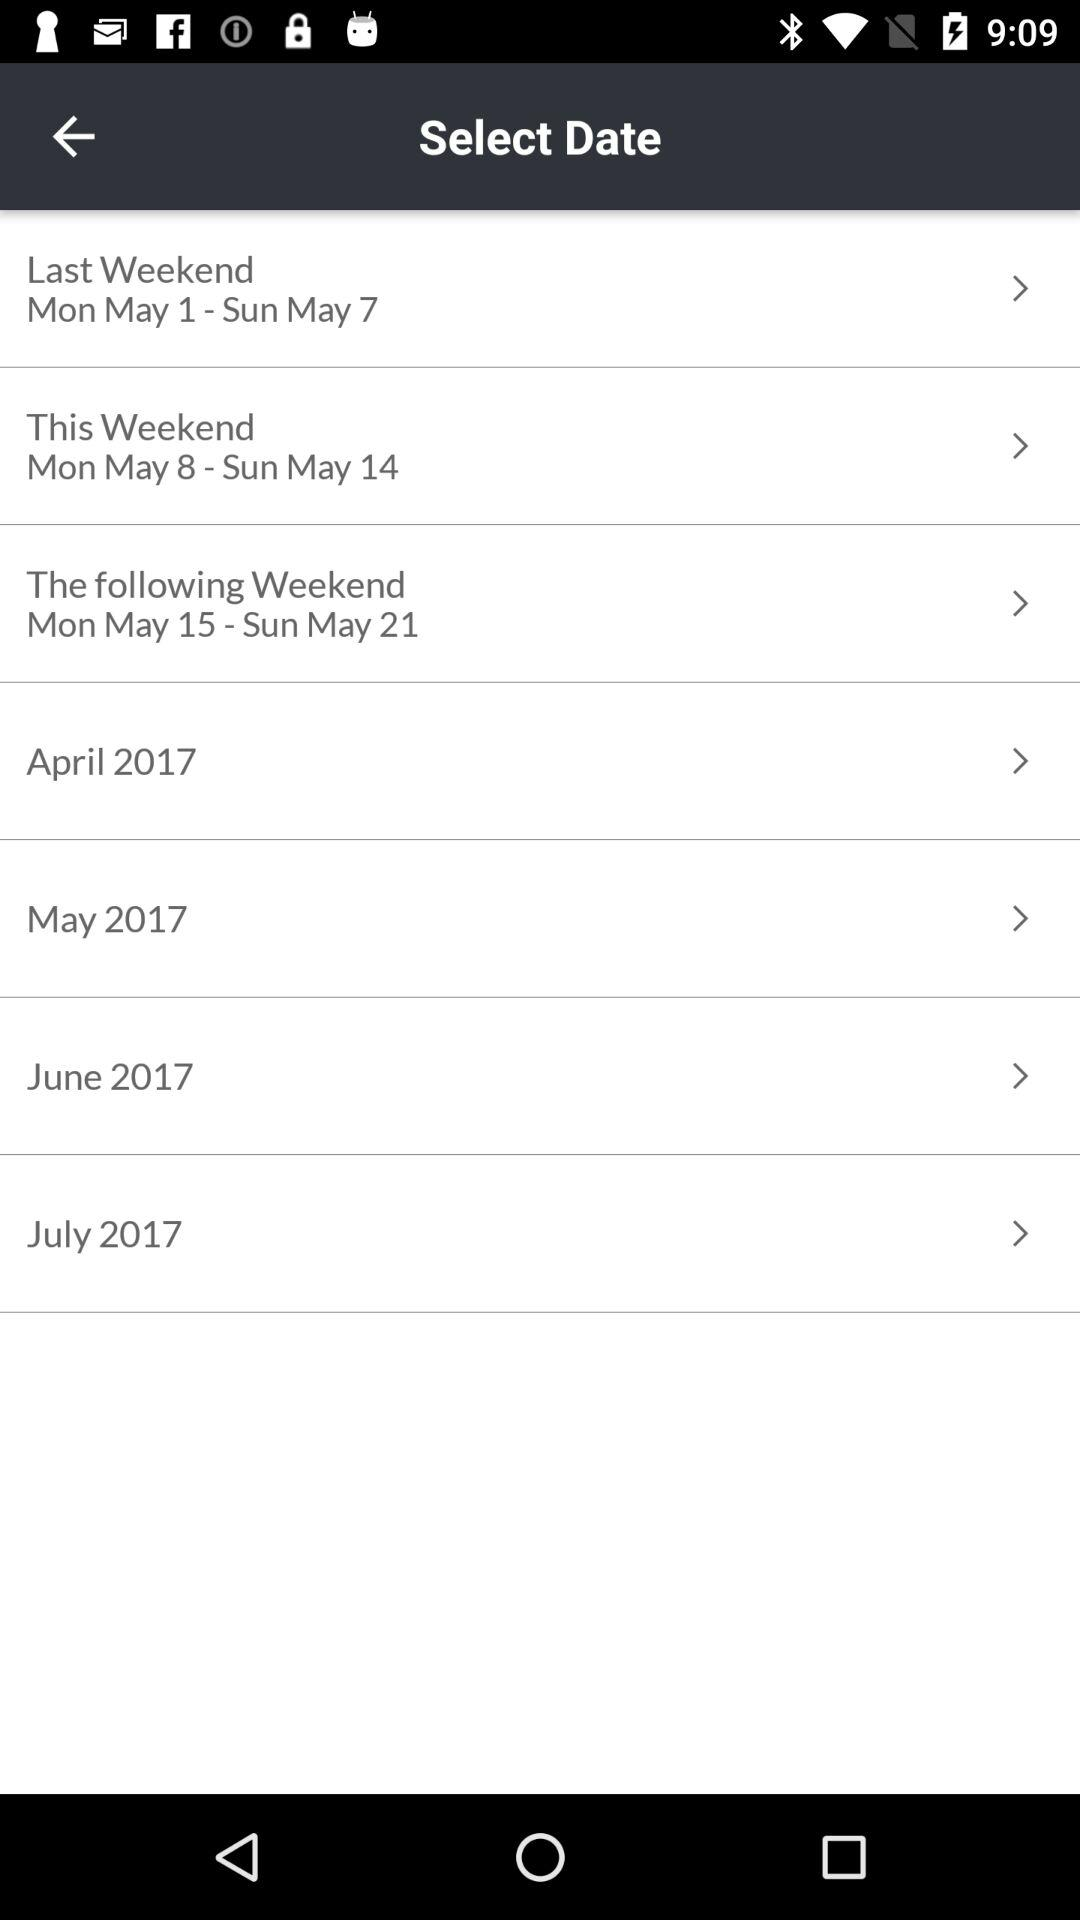What is the selected date range for the "This Weekend" category? The selected date range for the "This Weekend" category is Monday, 8th May to Sunday, 14th May. 